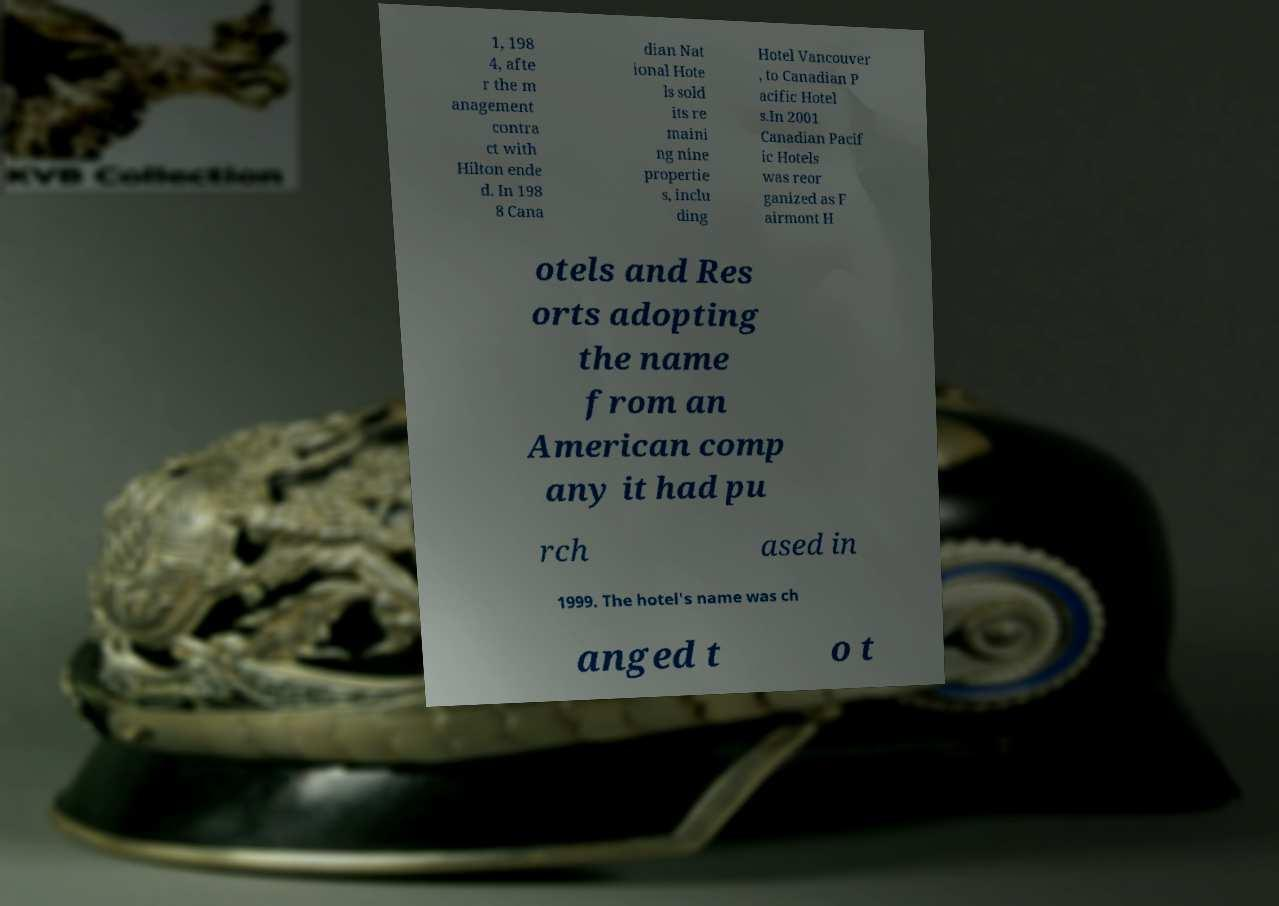For documentation purposes, I need the text within this image transcribed. Could you provide that? 1, 198 4, afte r the m anagement contra ct with Hilton ende d. In 198 8 Cana dian Nat ional Hote ls sold its re maini ng nine propertie s, inclu ding Hotel Vancouver , to Canadian P acific Hotel s.In 2001 Canadian Pacif ic Hotels was reor ganized as F airmont H otels and Res orts adopting the name from an American comp any it had pu rch ased in 1999. The hotel's name was ch anged t o t 